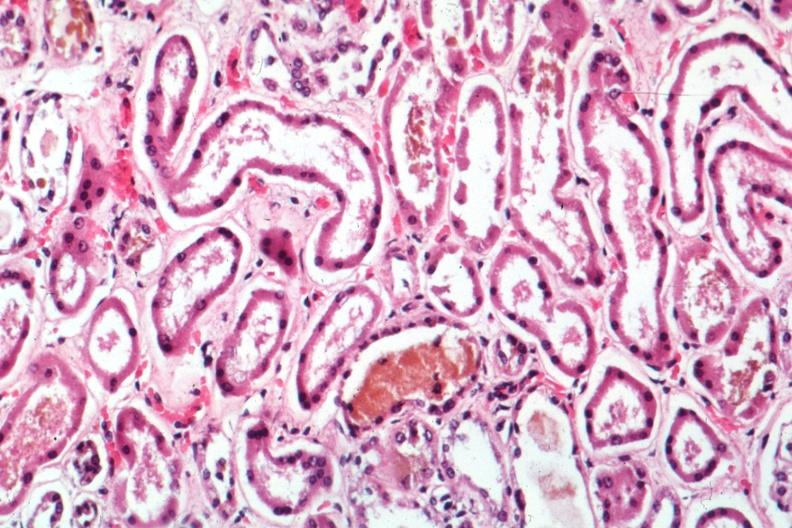s acute tubular necrosis present?
Answer the question using a single word or phrase. Yes 